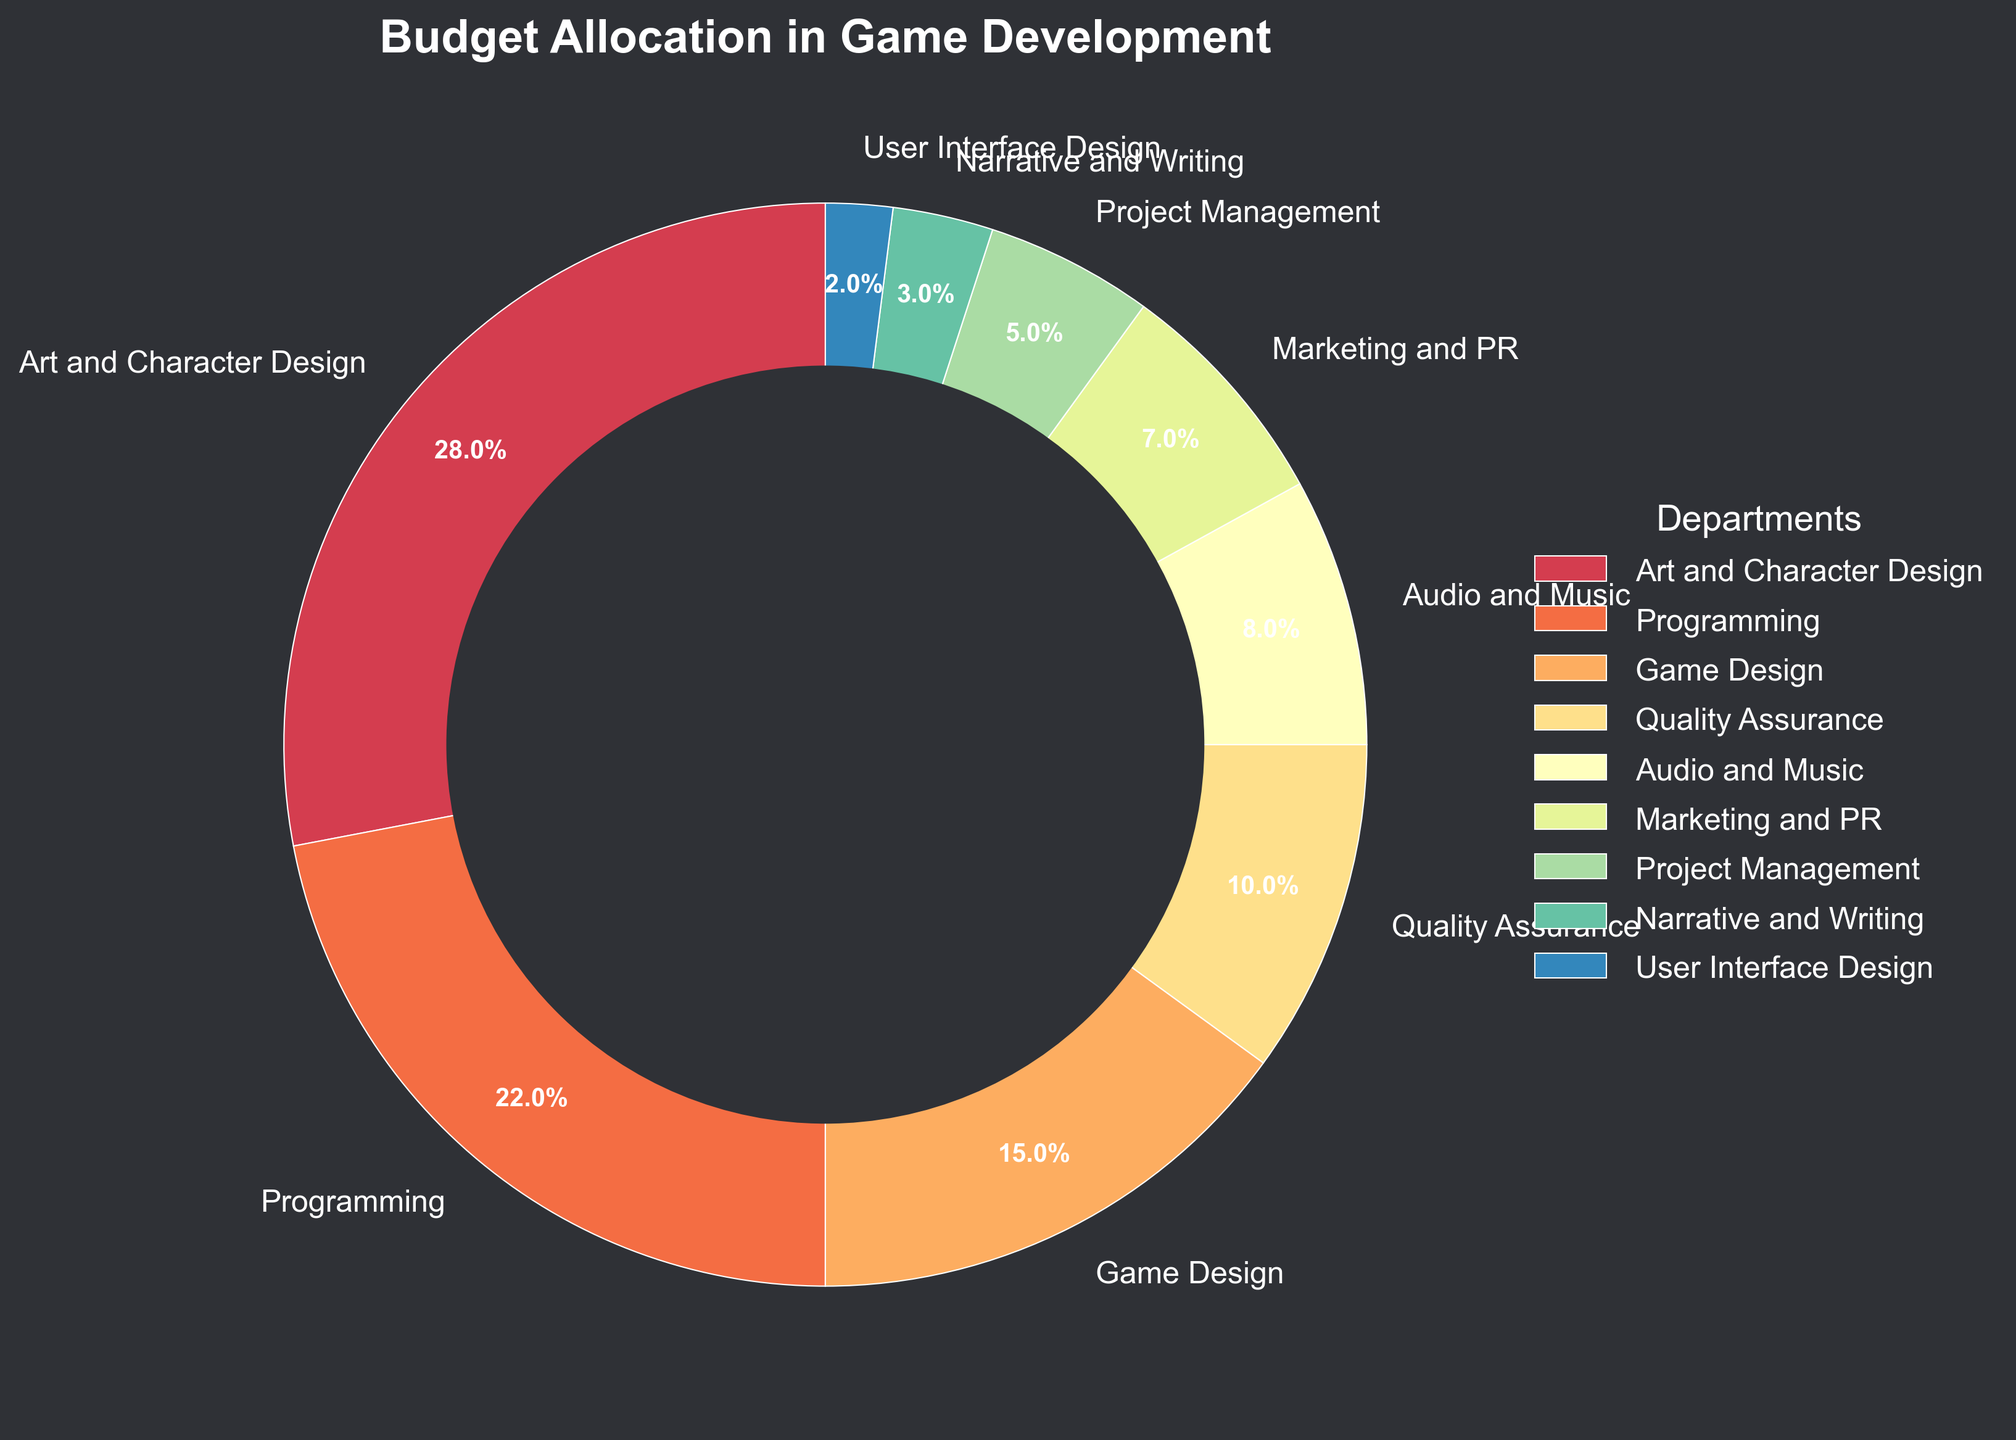Which department receives the highest budget allocation? By observing the pie chart, the segment with the largest arc and the percentage label indicates the highest budget allocation. The "Art and Character Design" department has a label of 28%, which is the largest percentage in the figure.
Answer: Art and Character Design What is the combined budget allocation for Audio and Music, and Marketing and PR? Add the budget percentages for "Audio and Music" and "Marketing and PR". The figure shows 8% for Audio and Music, and 7% for Marketing and PR. Therefore, 8% + 7% = 15%.
Answer: 15% Which department has a smaller budget allocation, Narrative and Writing, or User Interface Design? Comparing the segments for 'Narrative and Writing' and 'User Interface Design', we see that 'Narrative and Writing' is assigned 3% of the budget while 'User Interface Design' gets 2%. 2% is less than 3%, so User Interface Design has a smaller allocation.
Answer: User Interface Design By how much does the budget allocation for Programming exceed that for Quality Assurance? Subtract the percentage allocated to Quality Assurance from the percentage allocated to Programming. The chart shows Programming at 22% and Quality Assurance at 10%. The difference is 22% - 10% = 12%.
Answer: 12% What is the total budget percentage allocated to departments with allocations less than 5%? List the departments with allocations below 5%, namely Project Management (5%), Narrative and Writing (3%), and User Interface Design (2%). Sum these values: 5% + 3% + 2% = 10%.
Answer: 10% If the total budget is $1,000,000, how much money is allocated to Game Design and how much to Marketing and PR? Game Design receives 15% of the total budget and Marketing and PR gets 7%. Calculate the amounts: (15/100) * $1,000,000 = $150,000 for Game Design; (7/100) * $1,000,000 = $70,000 for Marketing and PR.
Answer: $150,000 (Game Design) and $70,000 (Marketing and PR) Among Programming, Game Design, and Marketing and PR, which department has the third highest budget allocation? Rank the given departments by their budget percentages from the chart. The percentages are: Programming (22%), Game Design (15%), Marketing and PR (7%). Marketing and PR has the third highest allocation among the three.
Answer: Marketing and PR How much more (in percentage points) is allocated to Art and Character Design compared to User Interface Design? Calculate the difference in budget allocation percentages between the two departments. Art and Character Design has 28%, and User Interface Design has 2%. The difference is 28% - 2% = 26 percentage points.
Answer: 26 